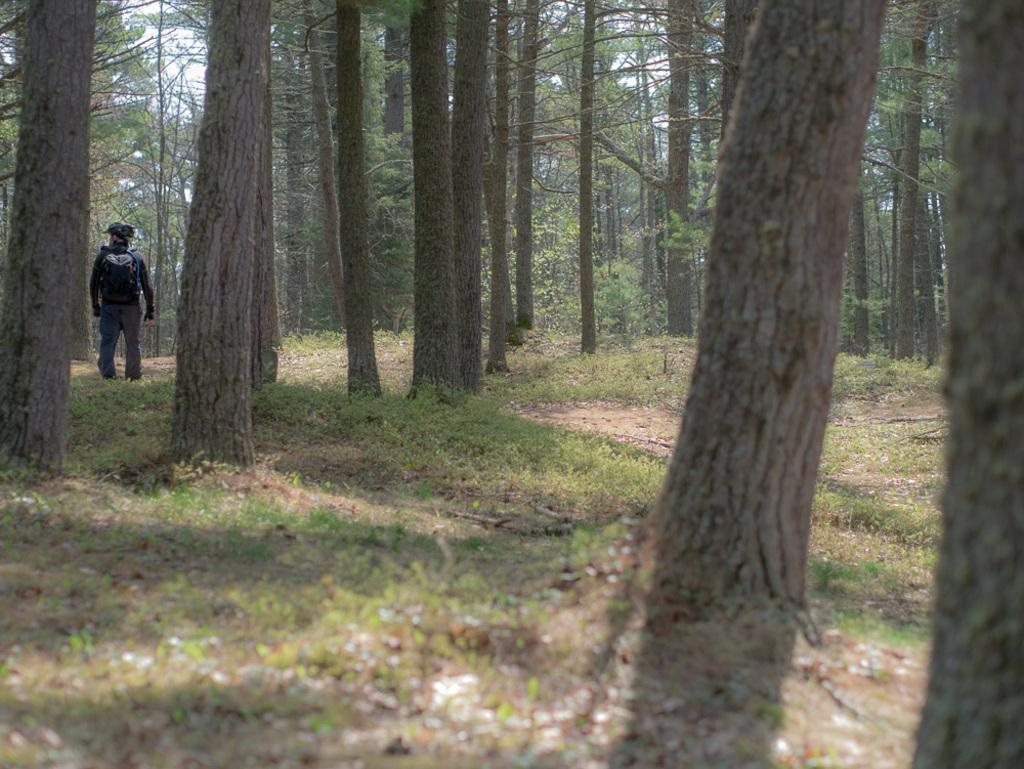What is the main subject of the image? There is a person standing in the image. What can be seen in the background of the image? There are trees in the background of the image. What is the color of the trees? The trees are green in color. What else is visible in the image? The sky is visible in the image. What is the color of the sky? The sky is white in color. How much wealth is depicted in the image? There is no indication of wealth in the image; it features a person standing in front of green trees and a white sky. 